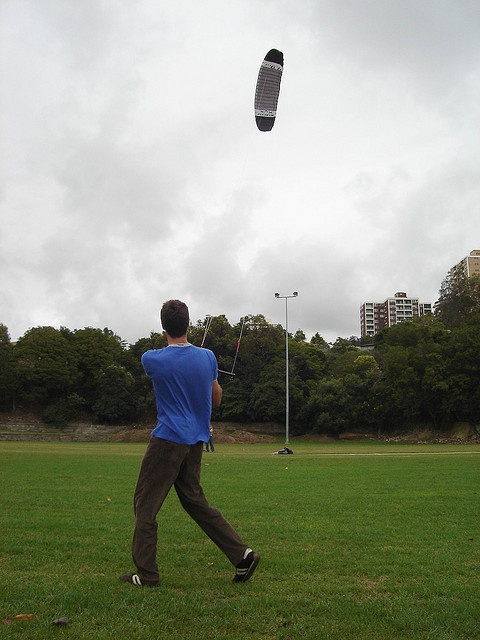Describe the objects in this image and their specific colors. I can see people in lightgray, black, navy, blue, and darkgreen tones and kite in lightgray, gray, black, and darkgray tones in this image. 